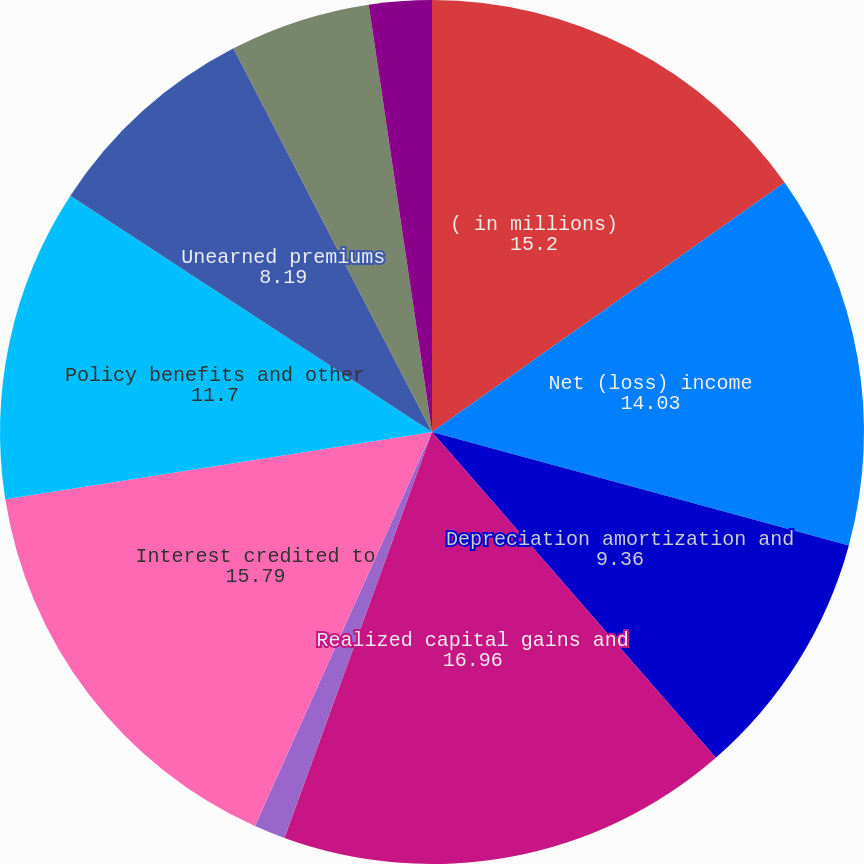Convert chart to OTSL. <chart><loc_0><loc_0><loc_500><loc_500><pie_chart><fcel>( in millions)<fcel>Net (loss) income<fcel>Depreciation amortization and<fcel>Realized capital gains and<fcel>Loss on disposition of<fcel>Interest credited to<fcel>Policy benefits and other<fcel>Unearned premiums<fcel>Deferred policy acquisition<fcel>Premium installment<nl><fcel>15.2%<fcel>14.03%<fcel>9.36%<fcel>16.96%<fcel>1.17%<fcel>15.79%<fcel>11.7%<fcel>8.19%<fcel>5.26%<fcel>2.34%<nl></chart> 